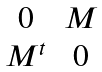<formula> <loc_0><loc_0><loc_500><loc_500>\begin{matrix} 0 & M \\ M ^ { t } & 0 \end{matrix}</formula> 